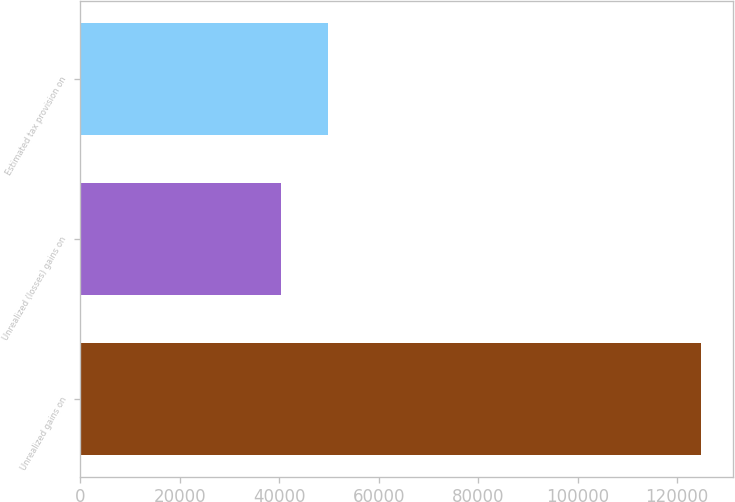Convert chart. <chart><loc_0><loc_0><loc_500><loc_500><bar_chart><fcel>Unrealized gains on<fcel>Unrealized (losses) gains on<fcel>Estimated tax provision on<nl><fcel>124874<fcel>40352<fcel>49905<nl></chart> 